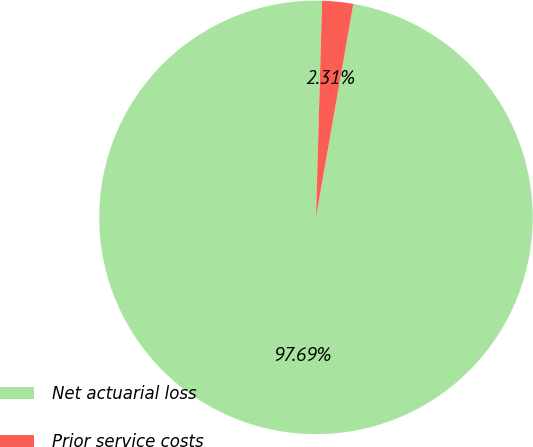Convert chart. <chart><loc_0><loc_0><loc_500><loc_500><pie_chart><fcel>Net actuarial loss<fcel>Prior service costs<nl><fcel>97.69%<fcel>2.31%<nl></chart> 